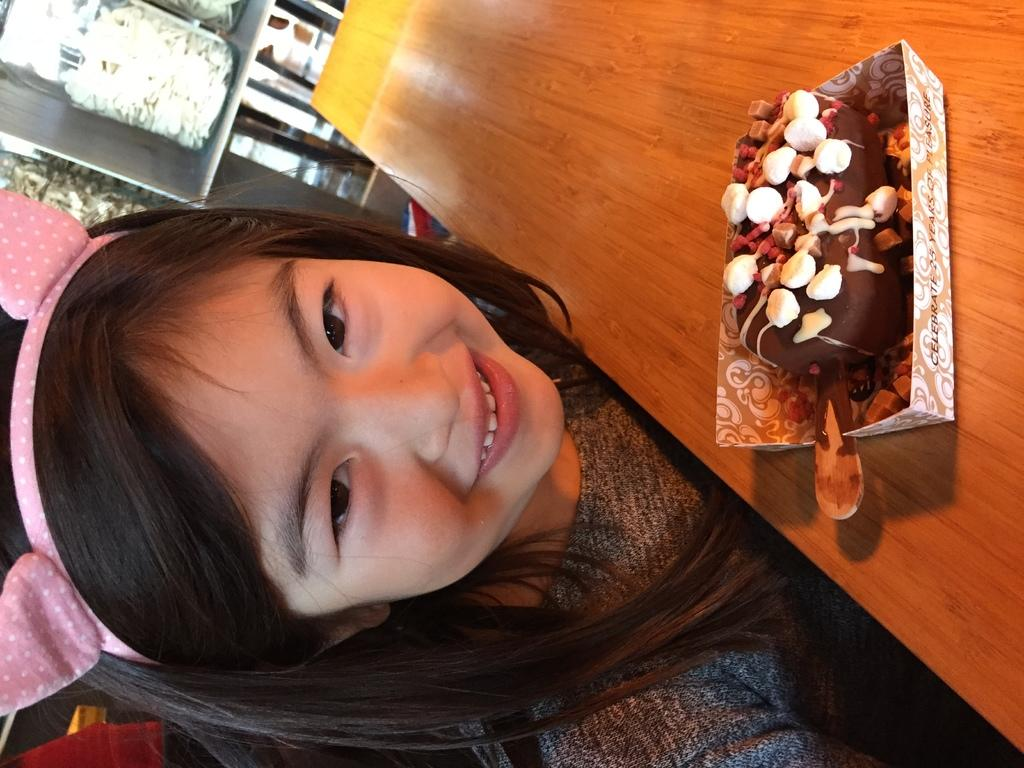Who is present in the image? There is a girl in the image. What is the girl doing in the image? The girl is smiling in the image. What is inside the box on the table? There is ice cream in a box on the table in the image. What can be seen in the background of the image? There are jars visible in the background of the image. What type of cloth is being used to create steam in the image? There is no cloth or steam present in the image. How many toes are visible on the girl's feet in the image? The girl's feet are not visible in the image, so we cannot determine the number of toes. 